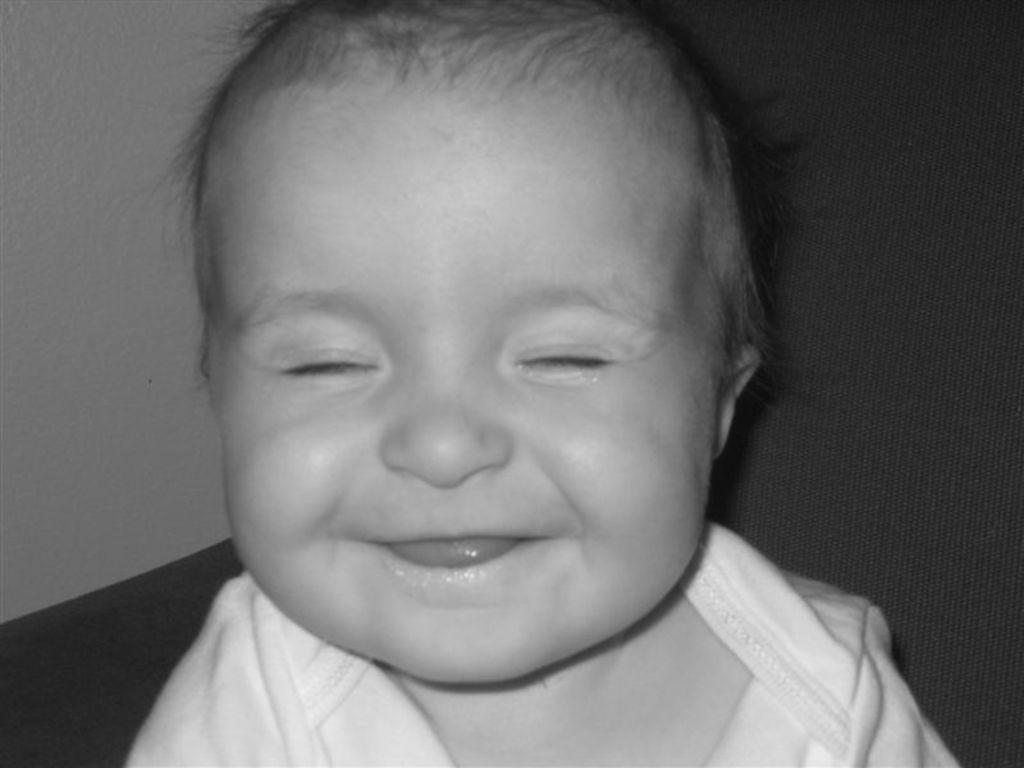What is the color scheme of the image? The image is black and white. What can be seen on the furniture in the image? There is a kid on the couch in the image. What is visible in the background of the image? There is a wall in the background of the image. What type of tank is visible in the image? There is no tank present in the image. How many cups can be seen on the couch with the kid? There are no cups visible in the image; only the kid is present on the couch. 